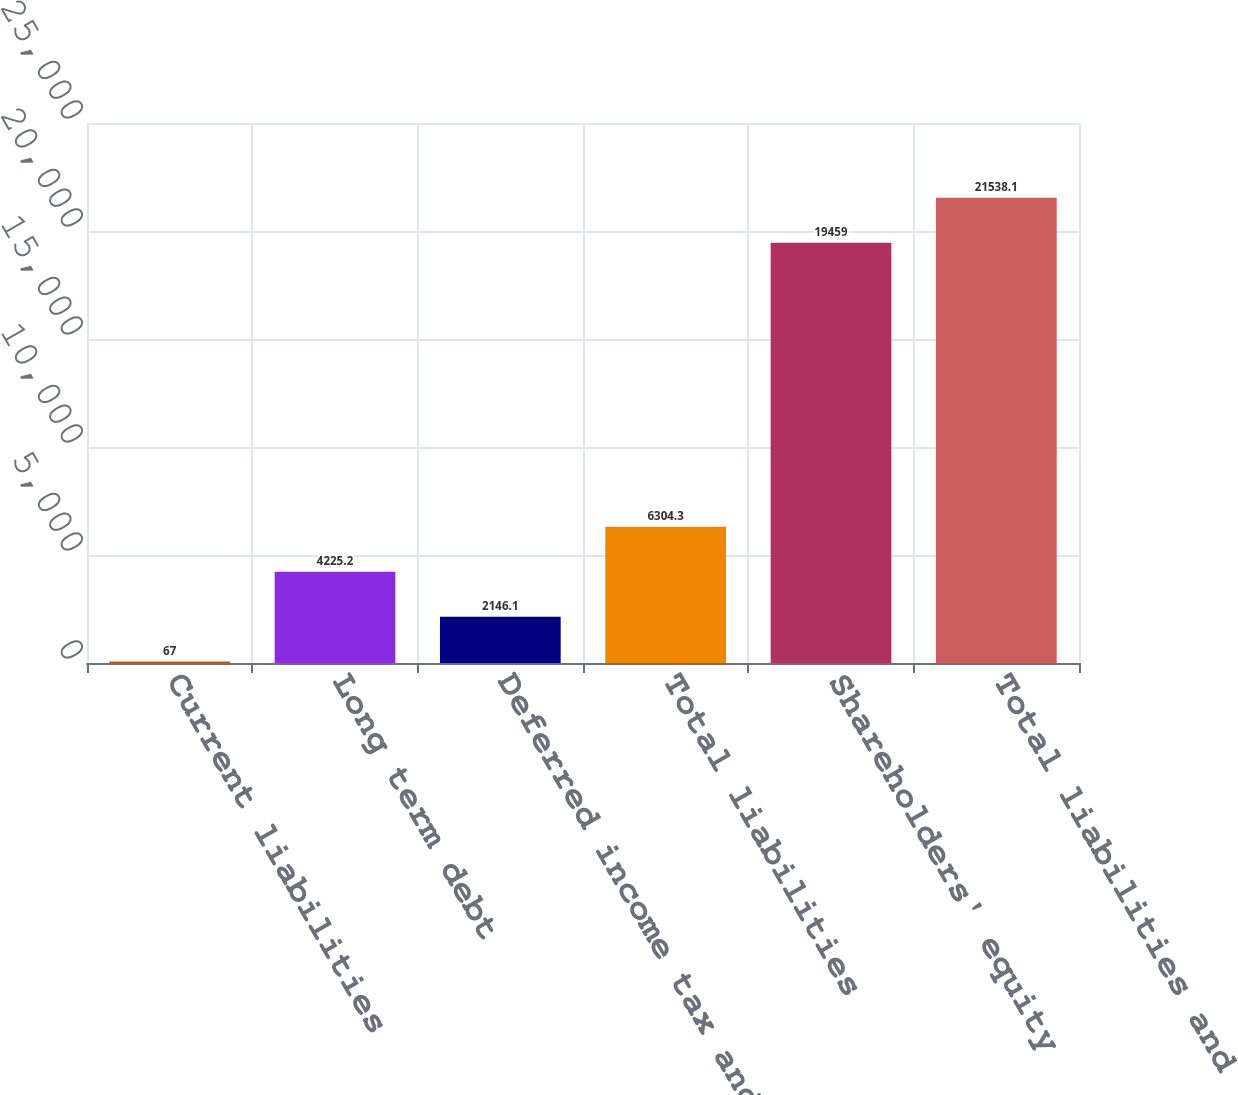<chart> <loc_0><loc_0><loc_500><loc_500><bar_chart><fcel>Current liabilities<fcel>Long term debt<fcel>Deferred income tax and other<fcel>Total liabilities<fcel>Shareholders' equity<fcel>Total liabilities and<nl><fcel>67<fcel>4225.2<fcel>2146.1<fcel>6304.3<fcel>19459<fcel>21538.1<nl></chart> 